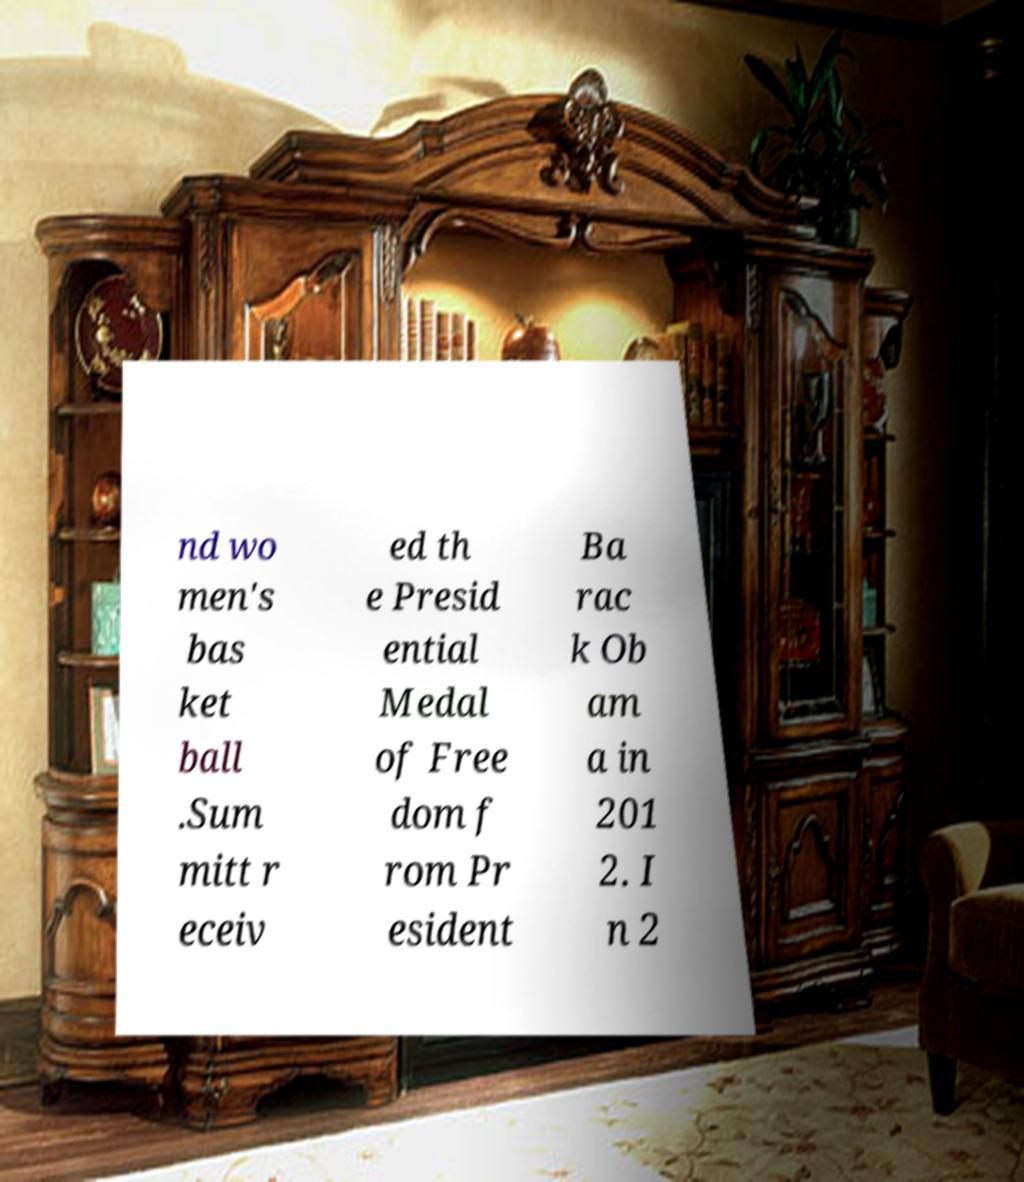Could you assist in decoding the text presented in this image and type it out clearly? nd wo men's bas ket ball .Sum mitt r eceiv ed th e Presid ential Medal of Free dom f rom Pr esident Ba rac k Ob am a in 201 2. I n 2 